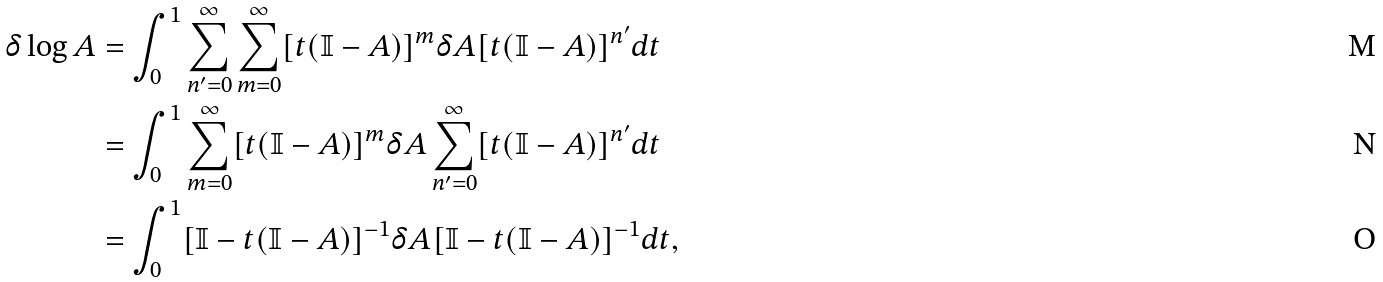Convert formula to latex. <formula><loc_0><loc_0><loc_500><loc_500>\delta \log A & = \int ^ { 1 } _ { 0 } \sum _ { n ^ { \prime } = 0 } ^ { \infty } \sum _ { m = 0 } ^ { \infty } [ t ( \mathbb { I } - A ) ] ^ { m } \delta A [ t ( \mathbb { I } - A ) ] ^ { n ^ { \prime } } d t \\ & = \int ^ { 1 } _ { 0 } \sum _ { m = 0 } ^ { \infty } [ t ( \mathbb { I } - A ) ] ^ { m } \delta A \sum _ { n ^ { \prime } = 0 } ^ { \infty } [ t ( \mathbb { I } - A ) ] ^ { n ^ { \prime } } d t \\ & = \int ^ { 1 } _ { 0 } [ \mathbb { I } - t ( \mathbb { I } - A ) ] ^ { - 1 } \delta A [ \mathbb { I } - t ( \mathbb { I } - A ) ] ^ { - 1 } d t ,</formula> 